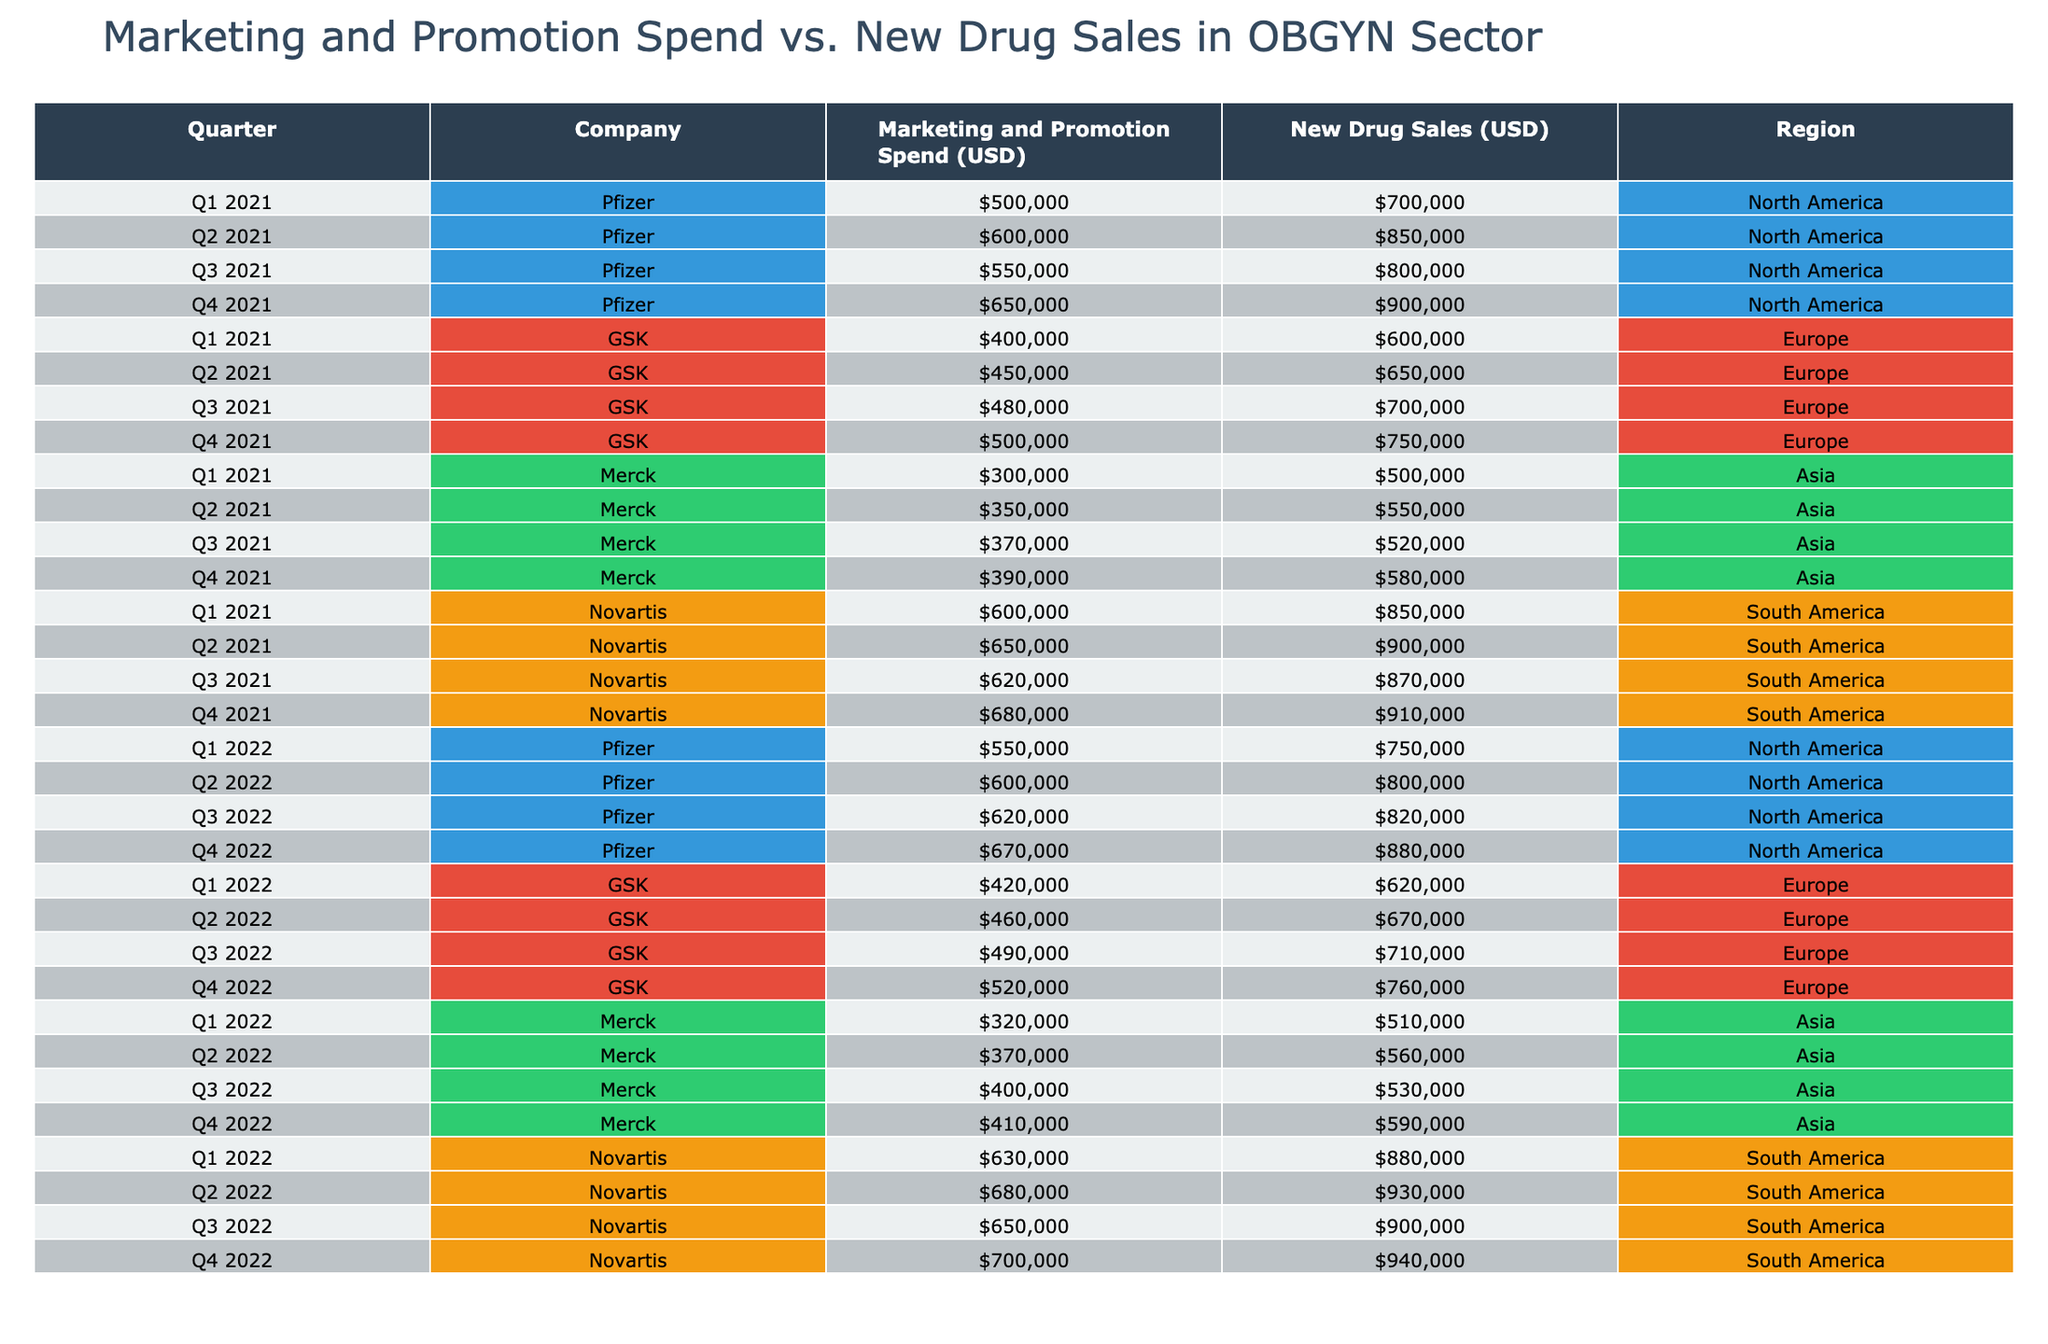What was the highest marketing and promotion spend recorded by Pfizer? Looking at the table, the highest marketing and promotion spend for Pfizer occurs in Q4 2022, where it is listed as $670,000.
Answer: $670,000 What is the total new drug sales for Novartis in 2021? We need to sum the new drug sales for Novartis across all quarters in 2021: (850000 + 900000 + 870000 + 910000) = 3630000.
Answer: $3,630,000 Did Merck spend more on marketing and promotion in 2022 than in 2021? In 2021, the total spend for Merck is (300000 + 350000 + 370000 + 390000) = 1410000, while in 2022 it is (320000 + 370000 + 400000 + 410000) = 1500000. Thus, yes, they spent more in 2022.
Answer: Yes What is the average new drug sales for GSK in 2021? GSK's new drug sales for 2021 are 600000, 650000, 700000, and 750000. Summing them gives 2700000, and dividing by 4 gives an average of 675000 for the year.
Answer: $675,000 Which company has the highest total marketing and promotion spend in North America for 2021? For North America, we calculate the total spend for Pfizer in 2021 which is (500000 + 600000 + 550000 + 650000) = 2300000. Other companies do not operate in North America for that year, making Pfizer the highest.
Answer: Pfizer What was the difference in new drug sales between Q2 2022 and Q2 2021 for GSK? In Q2 2022, GSK reported new drug sales of 670000 and in Q2 2021 it was 650000. The difference is 670000 - 650000 = 20000.
Answer: $20,000 Is the marketing and promotion spend for Novartis in Q4 2021 higher than its spend in Q1 2022? Novartis had a marketing spend of 680000 in Q4 2021 and 630000 in Q1 2022. Since 680000 is greater than 630000, the statement is true.
Answer: Yes What are the total new drug sales across all companies in Asia for 2021? Total new drug sales in Asia for Merck in 2021 are 500000, 550000, 520000, 580000, which sum up to (500000 + 550000 + 520000 + 580000) = 2150000.
Answer: $2,150,000 